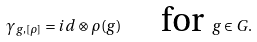Convert formula to latex. <formula><loc_0><loc_0><loc_500><loc_500>\gamma _ { g , [ \rho ] } = i d \otimes \rho ( g ) \quad \text { for } g \in G .</formula> 